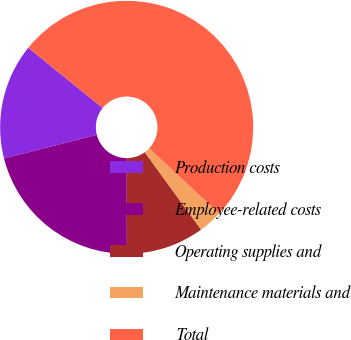<chart> <loc_0><loc_0><loc_500><loc_500><pie_chart><fcel>Production costs<fcel>Employee-related costs<fcel>Operating supplies and<fcel>Maintenance materials and<fcel>Total<nl><fcel>14.78%<fcel>21.07%<fcel>9.98%<fcel>3.05%<fcel>51.12%<nl></chart> 